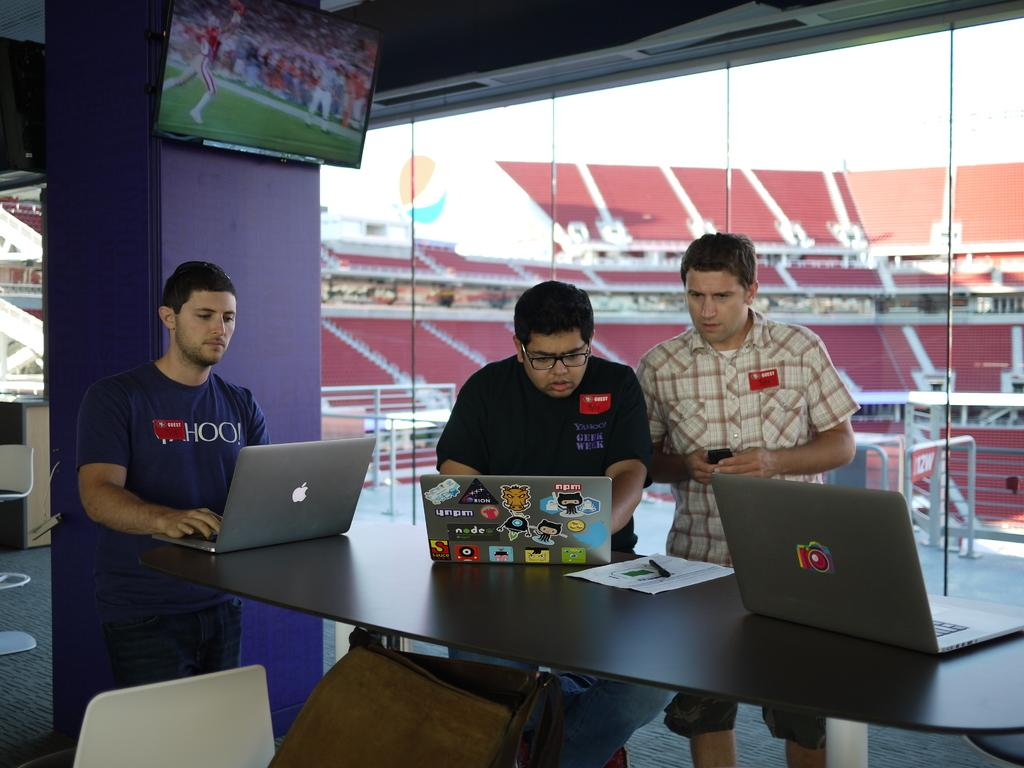How many people are in the image? There are three persons in the image. What are the persons doing in the image? The persons are standing and working on laptops. What can be seen in the background of the image? There is a stadium and a T.V. in the background of the image. What type of bears can be seen playing with a skirt in the image? There are no bears or skirts present in the image; it features three persons working on laptops with a stadium and a T.V. in the background. 